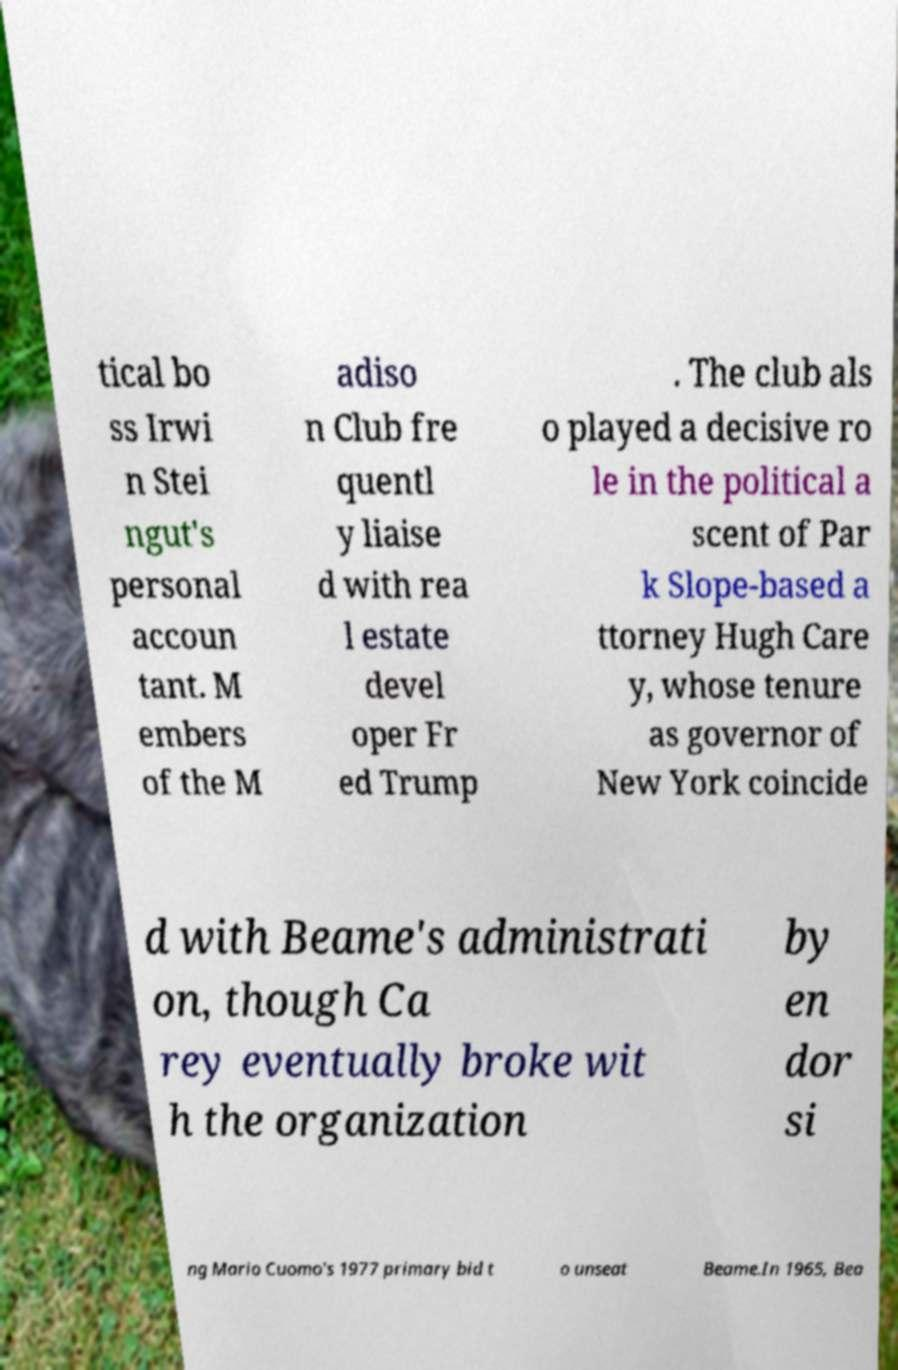Could you extract and type out the text from this image? tical bo ss Irwi n Stei ngut's personal accoun tant. M embers of the M adiso n Club fre quentl y liaise d with rea l estate devel oper Fr ed Trump . The club als o played a decisive ro le in the political a scent of Par k Slope-based a ttorney Hugh Care y, whose tenure as governor of New York coincide d with Beame's administrati on, though Ca rey eventually broke wit h the organization by en dor si ng Mario Cuomo's 1977 primary bid t o unseat Beame.In 1965, Bea 